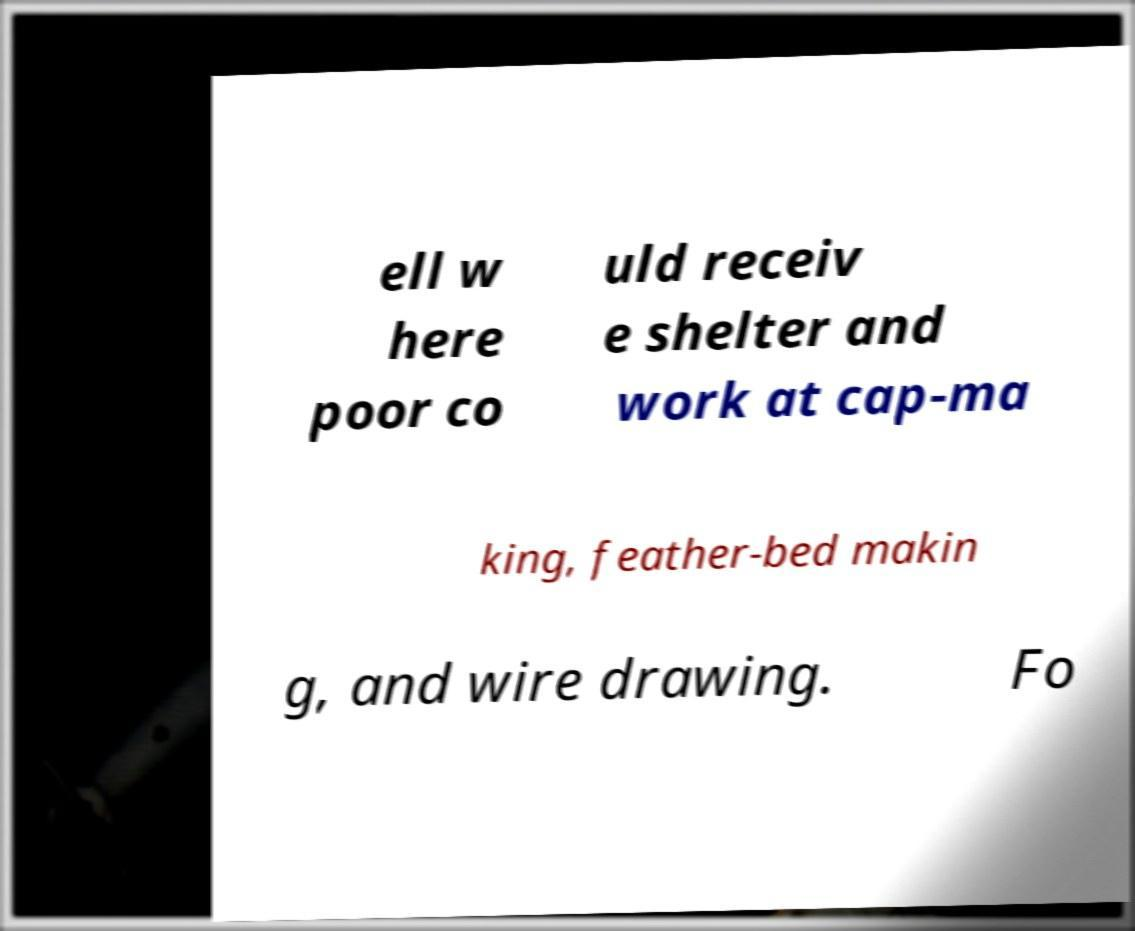What messages or text are displayed in this image? I need them in a readable, typed format. ell w here poor co uld receiv e shelter and work at cap-ma king, feather-bed makin g, and wire drawing. Fo 